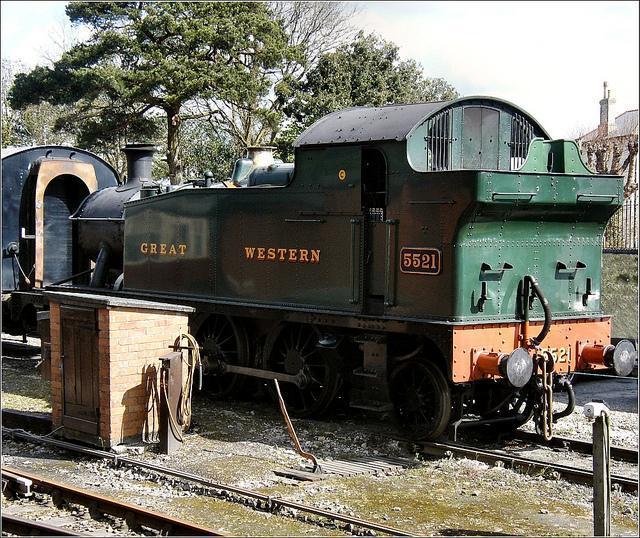How many sets of tracks are visible?
Give a very brief answer. 2. 